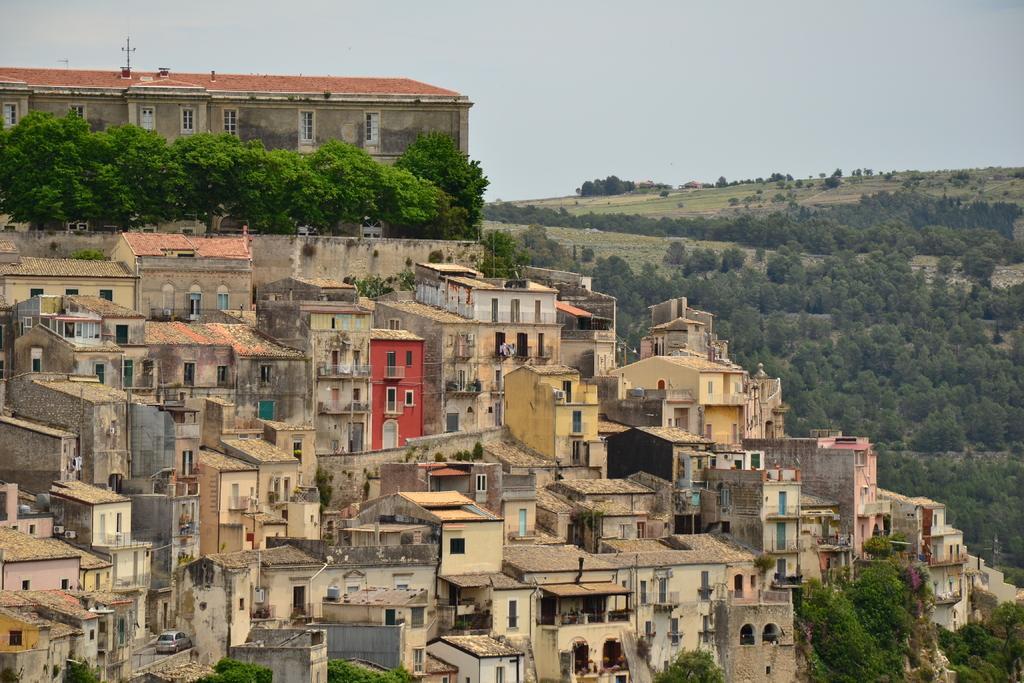In one or two sentences, can you explain what this image depicts? This picture is clicked outside the city. Here we see many buildings and behind that, we see many trees. Behind the trees, we see a building with red roof. On the right corner of the picture, we see many trees and grass and on top of the picture, we see sky. 